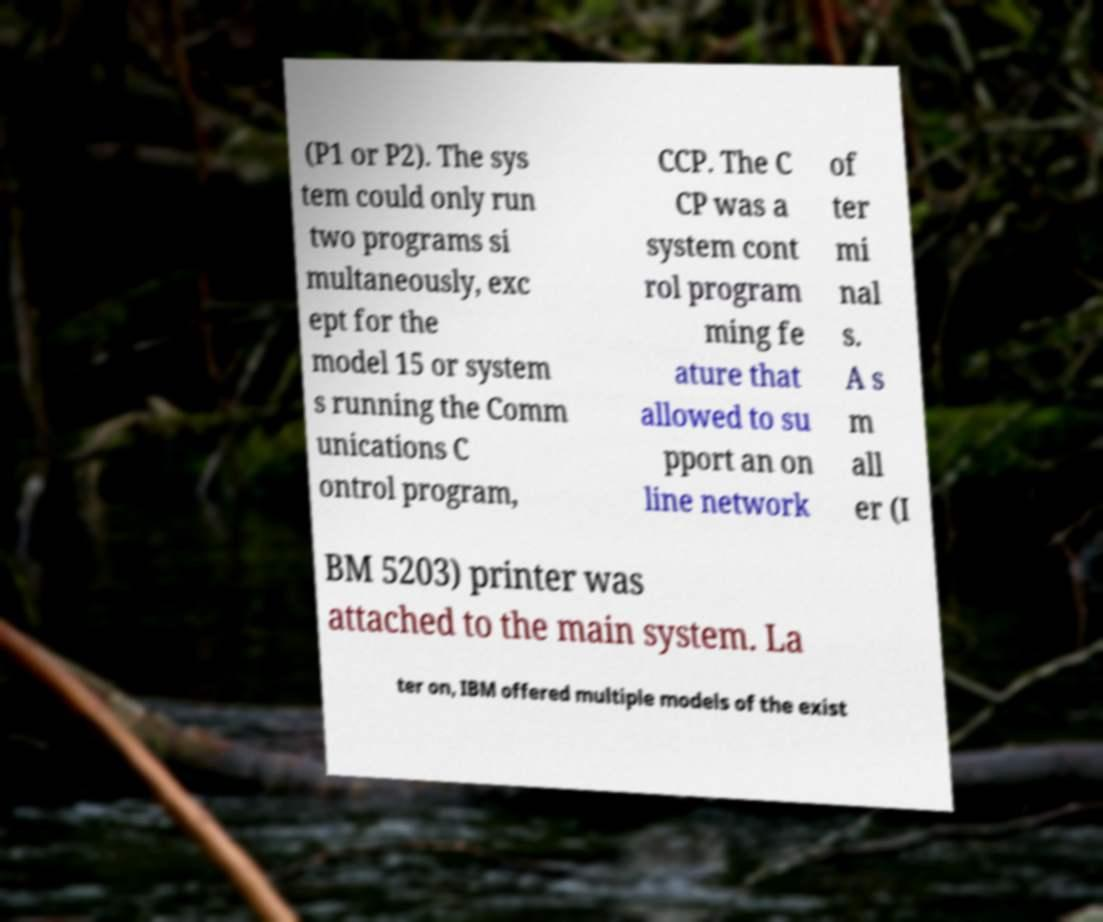There's text embedded in this image that I need extracted. Can you transcribe it verbatim? (P1 or P2). The sys tem could only run two programs si multaneously, exc ept for the model 15 or system s running the Comm unications C ontrol program, CCP. The C CP was a system cont rol program ming fe ature that allowed to su pport an on line network of ter mi nal s. A s m all er (I BM 5203) printer was attached to the main system. La ter on, IBM offered multiple models of the exist 